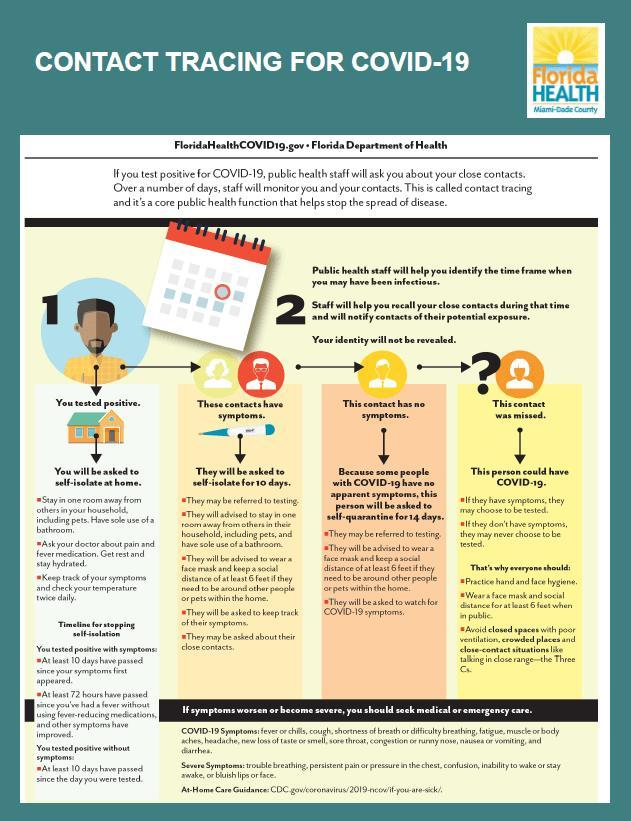What will be done if a COVID-positive person's contacts have symptoms?
Answer the question with a short phrase. They will be asked to self-isolate for 10 days If the contact of a COVID-positive person has no symptoms what should he do? self-quarantine for 14 days What will a person be asked to do first if he's tested positive? self-isolate at home 